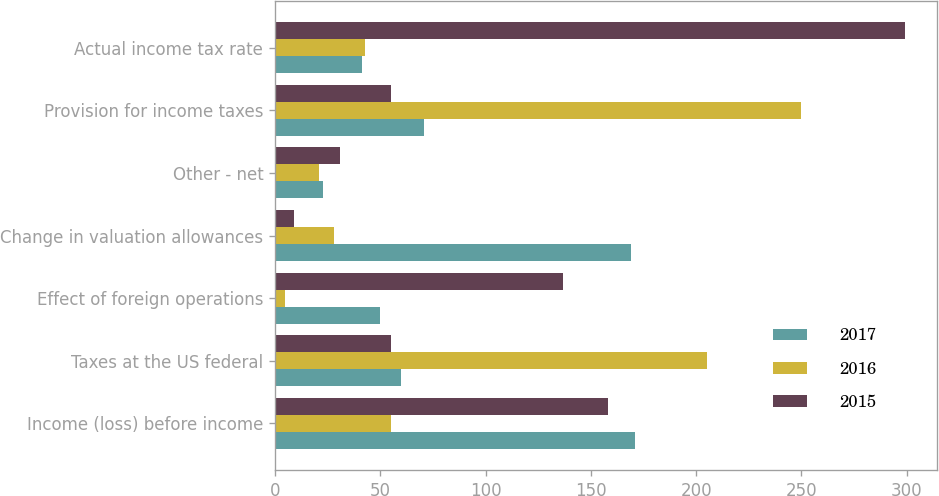Convert chart to OTSL. <chart><loc_0><loc_0><loc_500><loc_500><stacked_bar_chart><ecel><fcel>Income (loss) before income<fcel>Taxes at the US federal<fcel>Effect of foreign operations<fcel>Change in valuation allowances<fcel>Other - net<fcel>Provision for income taxes<fcel>Actual income tax rate<nl><fcel>2017<fcel>171<fcel>60<fcel>50<fcel>169<fcel>23<fcel>71<fcel>41.5<nl><fcel>2016<fcel>55<fcel>205<fcel>5<fcel>28<fcel>21<fcel>250<fcel>42.8<nl><fcel>2015<fcel>158<fcel>55<fcel>137<fcel>9<fcel>31<fcel>55<fcel>299.4<nl></chart> 